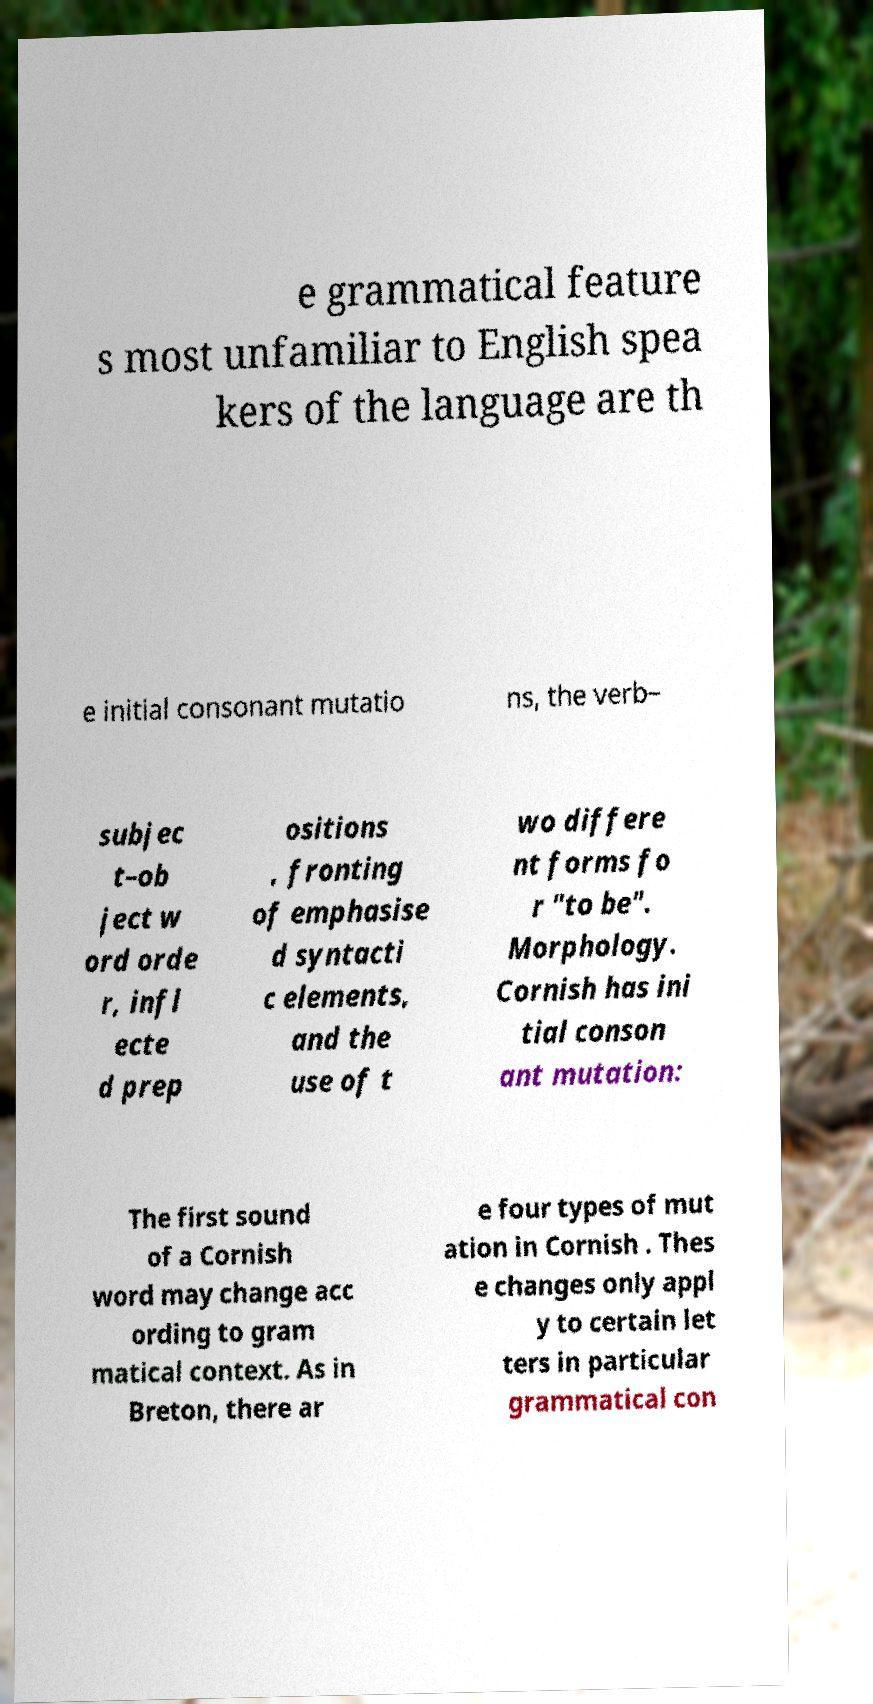For documentation purposes, I need the text within this image transcribed. Could you provide that? e grammatical feature s most unfamiliar to English spea kers of the language are th e initial consonant mutatio ns, the verb– subjec t–ob ject w ord orde r, infl ecte d prep ositions , fronting of emphasise d syntacti c elements, and the use of t wo differe nt forms fo r "to be". Morphology. Cornish has ini tial conson ant mutation: The first sound of a Cornish word may change acc ording to gram matical context. As in Breton, there ar e four types of mut ation in Cornish . Thes e changes only appl y to certain let ters in particular grammatical con 